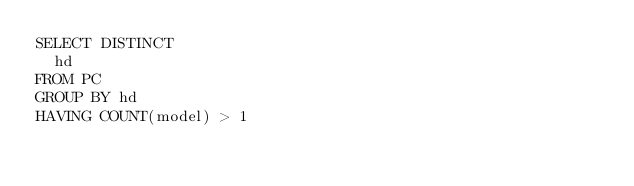<code> <loc_0><loc_0><loc_500><loc_500><_SQL_>SELECT DISTINCT
  hd
FROM PC
GROUP BY hd
HAVING COUNT(model) > 1</code> 